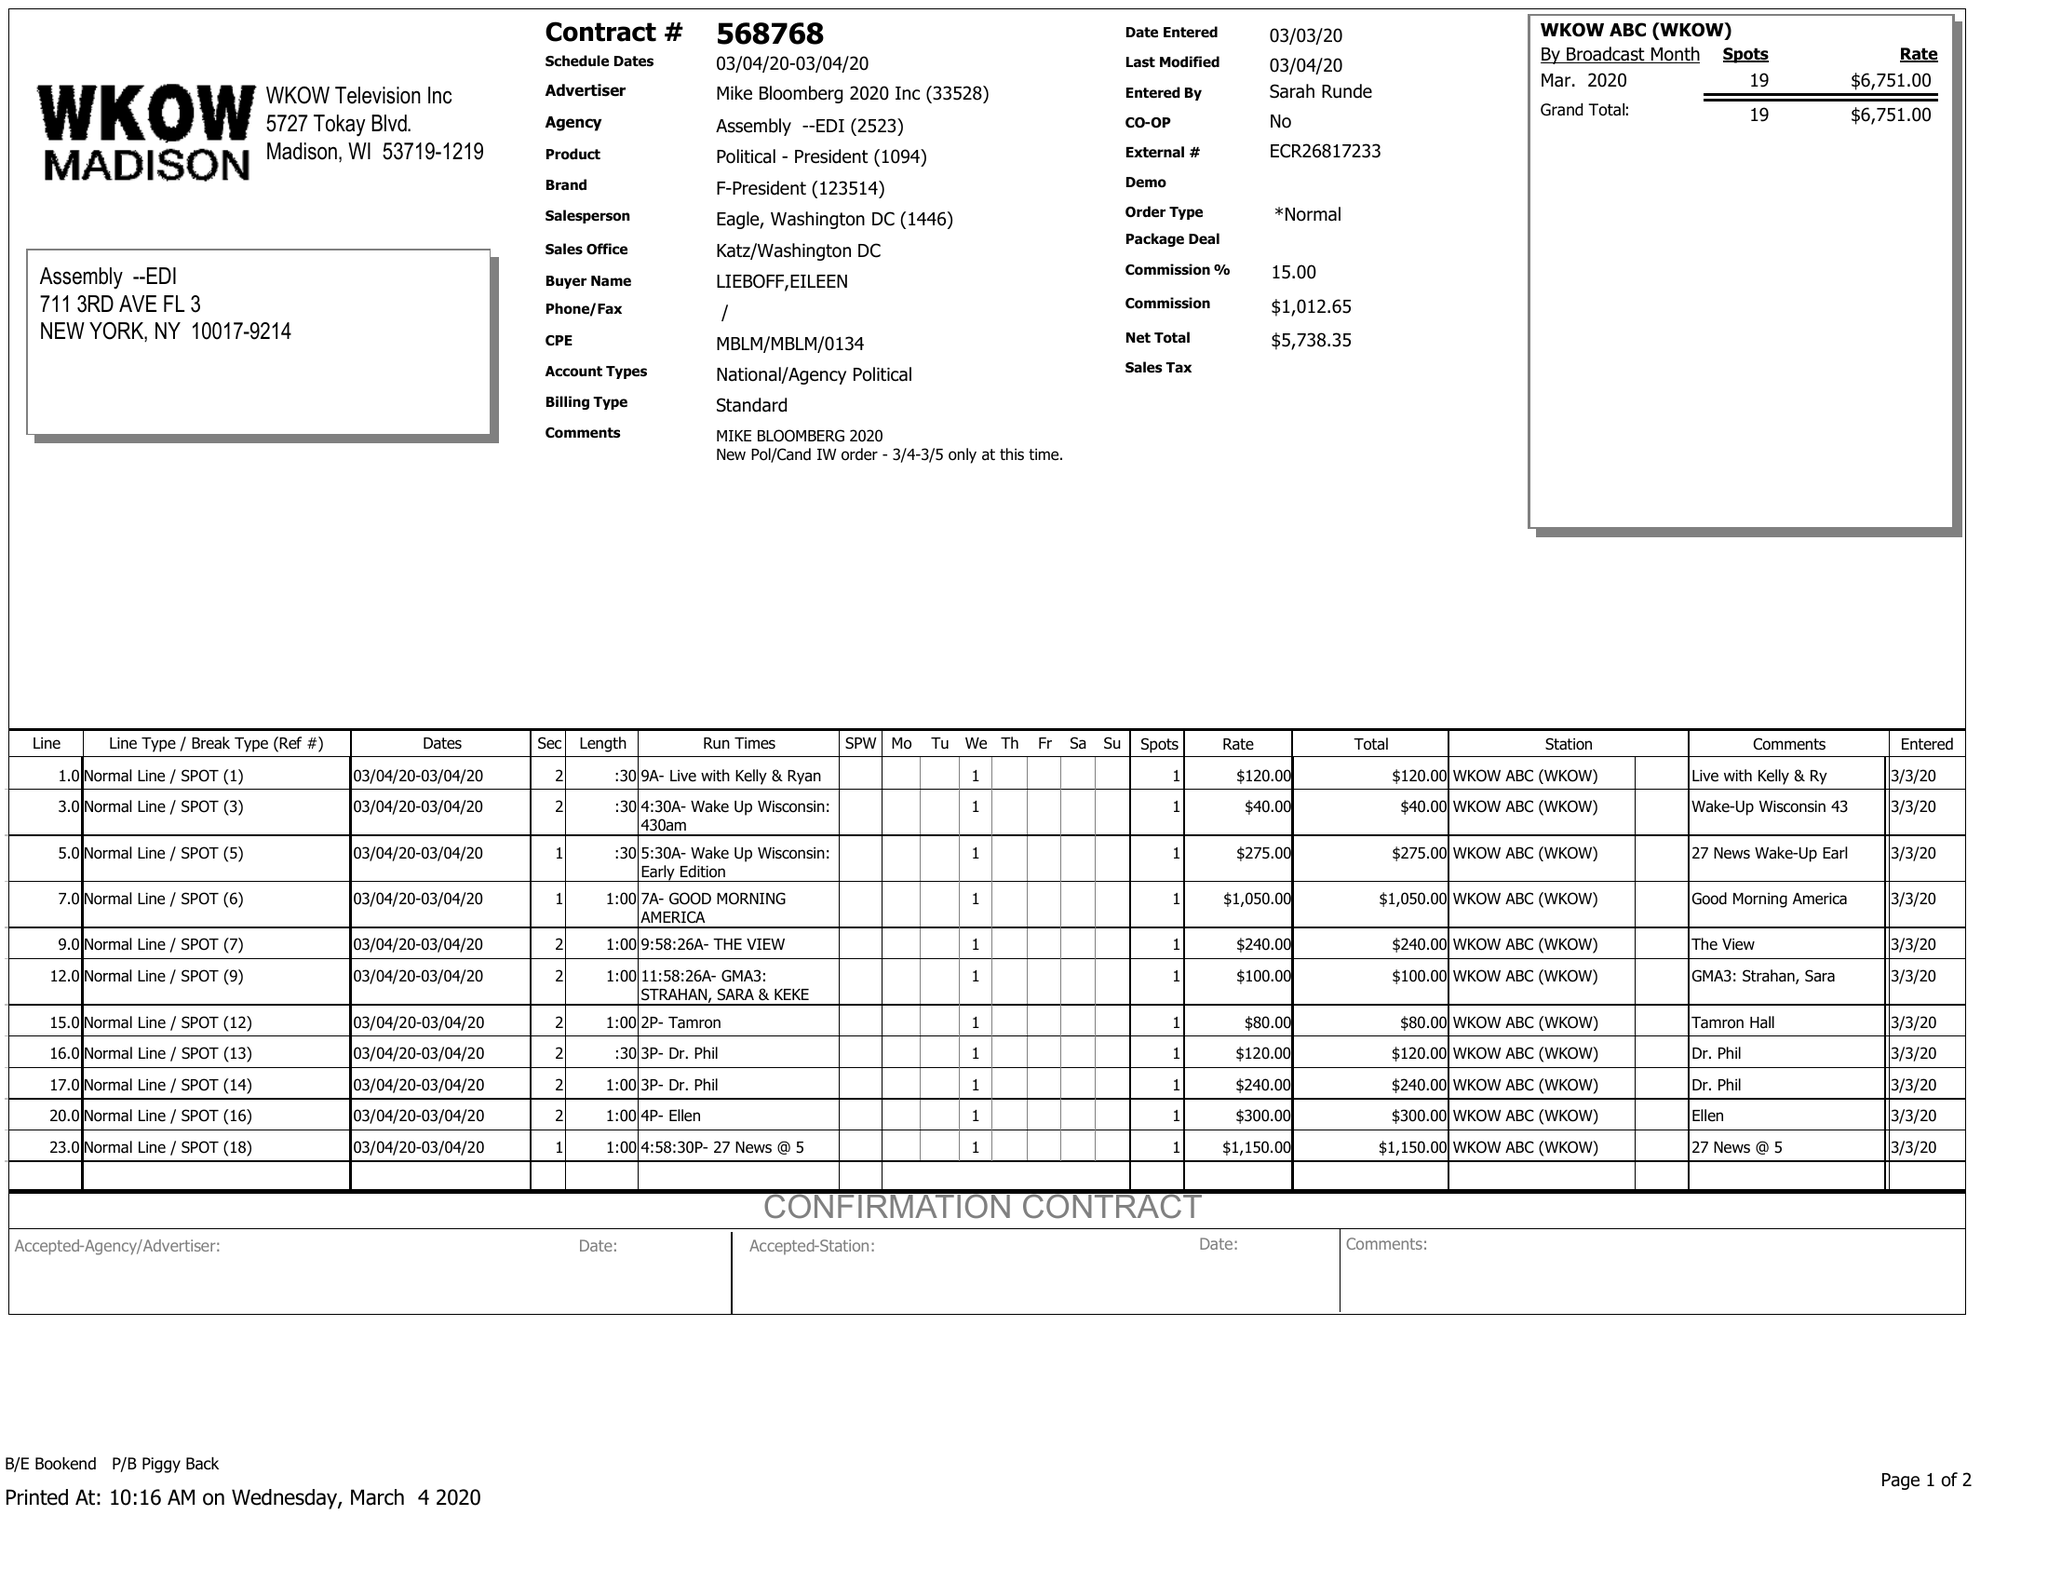What is the value for the contract_num?
Answer the question using a single word or phrase. 568768 